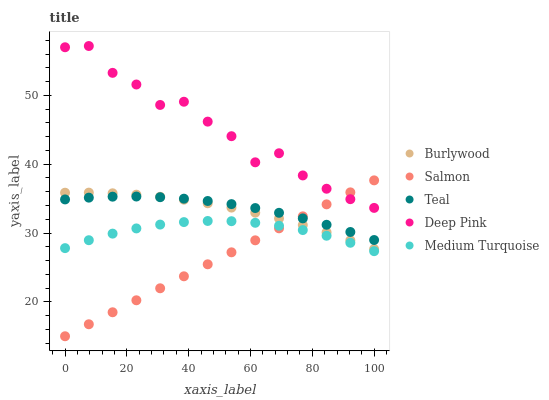Does Salmon have the minimum area under the curve?
Answer yes or no. Yes. Does Deep Pink have the maximum area under the curve?
Answer yes or no. Yes. Does Deep Pink have the minimum area under the curve?
Answer yes or no. No. Does Salmon have the maximum area under the curve?
Answer yes or no. No. Is Salmon the smoothest?
Answer yes or no. Yes. Is Deep Pink the roughest?
Answer yes or no. Yes. Is Deep Pink the smoothest?
Answer yes or no. No. Is Salmon the roughest?
Answer yes or no. No. Does Salmon have the lowest value?
Answer yes or no. Yes. Does Deep Pink have the lowest value?
Answer yes or no. No. Does Deep Pink have the highest value?
Answer yes or no. Yes. Does Salmon have the highest value?
Answer yes or no. No. Is Medium Turquoise less than Burlywood?
Answer yes or no. Yes. Is Deep Pink greater than Teal?
Answer yes or no. Yes. Does Salmon intersect Deep Pink?
Answer yes or no. Yes. Is Salmon less than Deep Pink?
Answer yes or no. No. Is Salmon greater than Deep Pink?
Answer yes or no. No. Does Medium Turquoise intersect Burlywood?
Answer yes or no. No. 